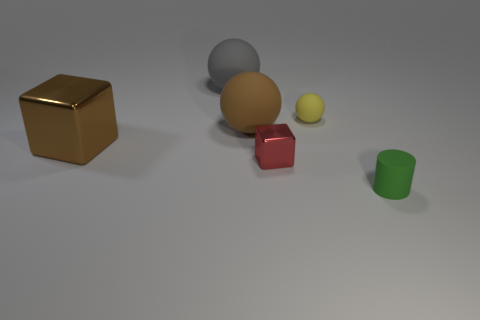If you were to create a short story, what roles might these objects play in it? In a whimsical tale, these objects could be characters on a quest. The golden cube might be the wise elder holding ancient knowledge, the large gray sphere could be the guardian of balance, the small yellow sphere, the youthful and energetic apprentice, the red rubber cube could be the fiery warrior, and the green cylinder might be the mediator who ensures harmony in the group as they journey across a vast table land. 